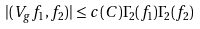<formula> <loc_0><loc_0><loc_500><loc_500>| ( V _ { g } f _ { 1 } , f _ { 2 } ) | \leq c ( C ) \Gamma _ { 2 } ( f _ { 1 } ) \Gamma _ { 2 } ( f _ { 2 } )</formula> 